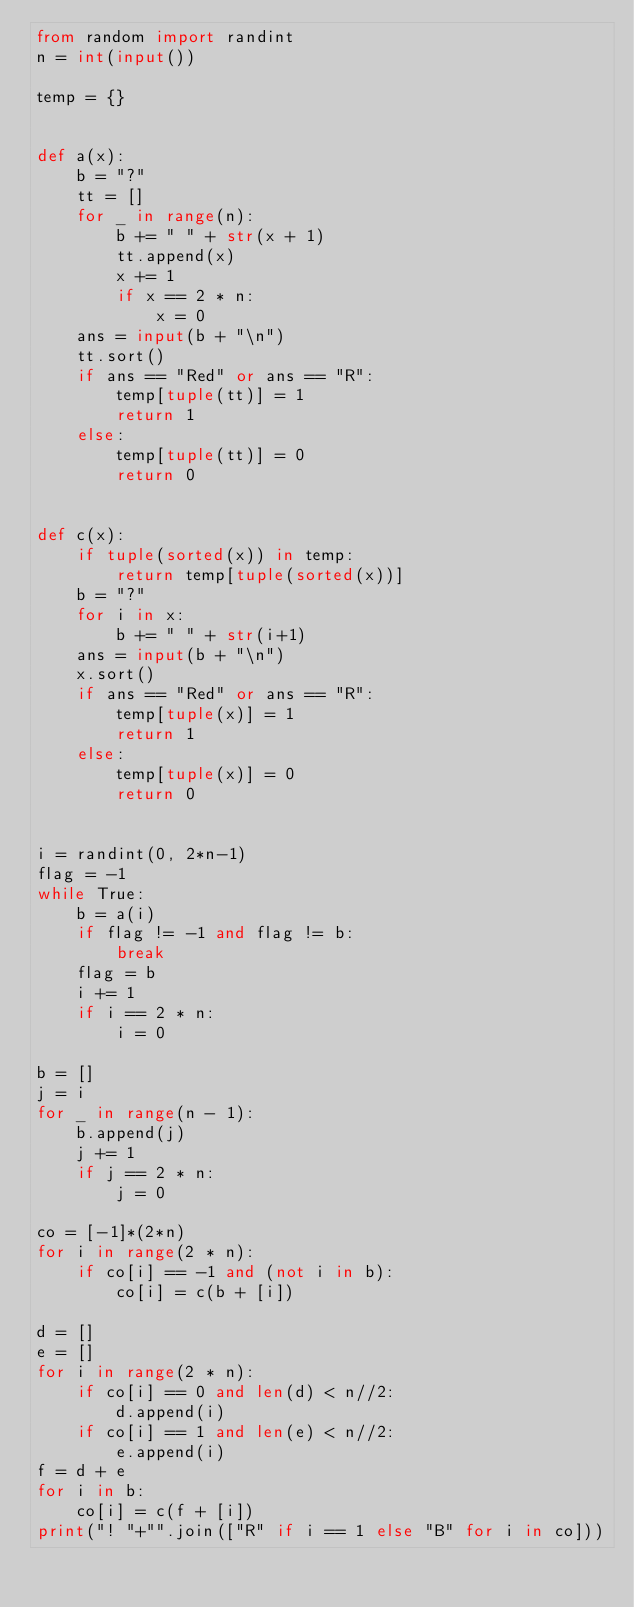Convert code to text. <code><loc_0><loc_0><loc_500><loc_500><_Python_>from random import randint
n = int(input())

temp = {}


def a(x):
    b = "?"
    tt = []
    for _ in range(n):
        b += " " + str(x + 1)
        tt.append(x)
        x += 1
        if x == 2 * n:
            x = 0
    ans = input(b + "\n")
    tt.sort()
    if ans == "Red" or ans == "R":
        temp[tuple(tt)] = 1
        return 1
    else:
        temp[tuple(tt)] = 0
        return 0


def c(x):
    if tuple(sorted(x)) in temp:
        return temp[tuple(sorted(x))]
    b = "?"
    for i in x:
        b += " " + str(i+1)
    ans = input(b + "\n")
    x.sort()
    if ans == "Red" or ans == "R":
        temp[tuple(x)] = 1
        return 1
    else:
        temp[tuple(x)] = 0
        return 0


i = randint(0, 2*n-1)
flag = -1
while True:
    b = a(i)
    if flag != -1 and flag != b:
        break
    flag = b
    i += 1
    if i == 2 * n:
        i = 0

b = []
j = i
for _ in range(n - 1):
    b.append(j)
    j += 1
    if j == 2 * n:
        j = 0

co = [-1]*(2*n)
for i in range(2 * n):
    if co[i] == -1 and (not i in b):
        co[i] = c(b + [i])

d = []
e = []
for i in range(2 * n):
    if co[i] == 0 and len(d) < n//2:
        d.append(i)
    if co[i] == 1 and len(e) < n//2:
        e.append(i)
f = d + e
for i in b:
    co[i] = c(f + [i])
print("! "+"".join(["R" if i == 1 else "B" for i in co]))
</code> 